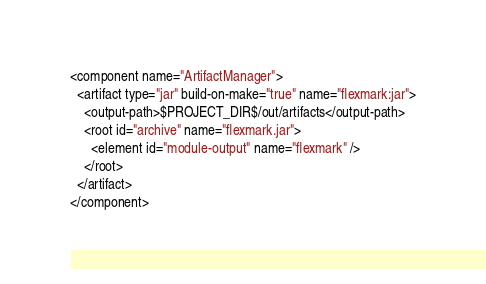Convert code to text. <code><loc_0><loc_0><loc_500><loc_500><_XML_><component name="ArtifactManager">
  <artifact type="jar" build-on-make="true" name="flexmark:jar">
    <output-path>$PROJECT_DIR$/out/artifacts</output-path>
    <root id="archive" name="flexmark.jar">
      <element id="module-output" name="flexmark" />
    </root>
  </artifact>
</component></code> 